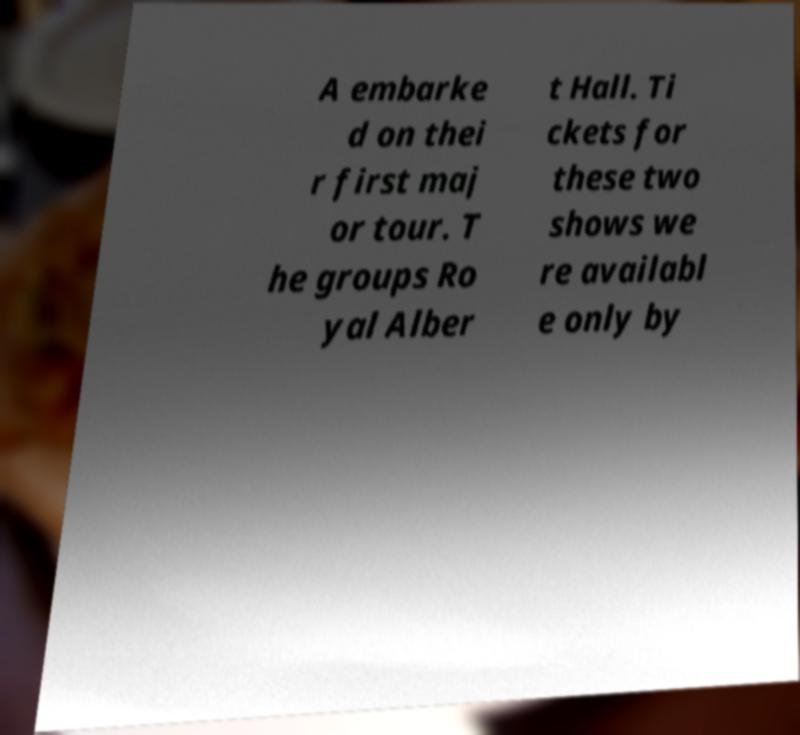Can you accurately transcribe the text from the provided image for me? A embarke d on thei r first maj or tour. T he groups Ro yal Alber t Hall. Ti ckets for these two shows we re availabl e only by 